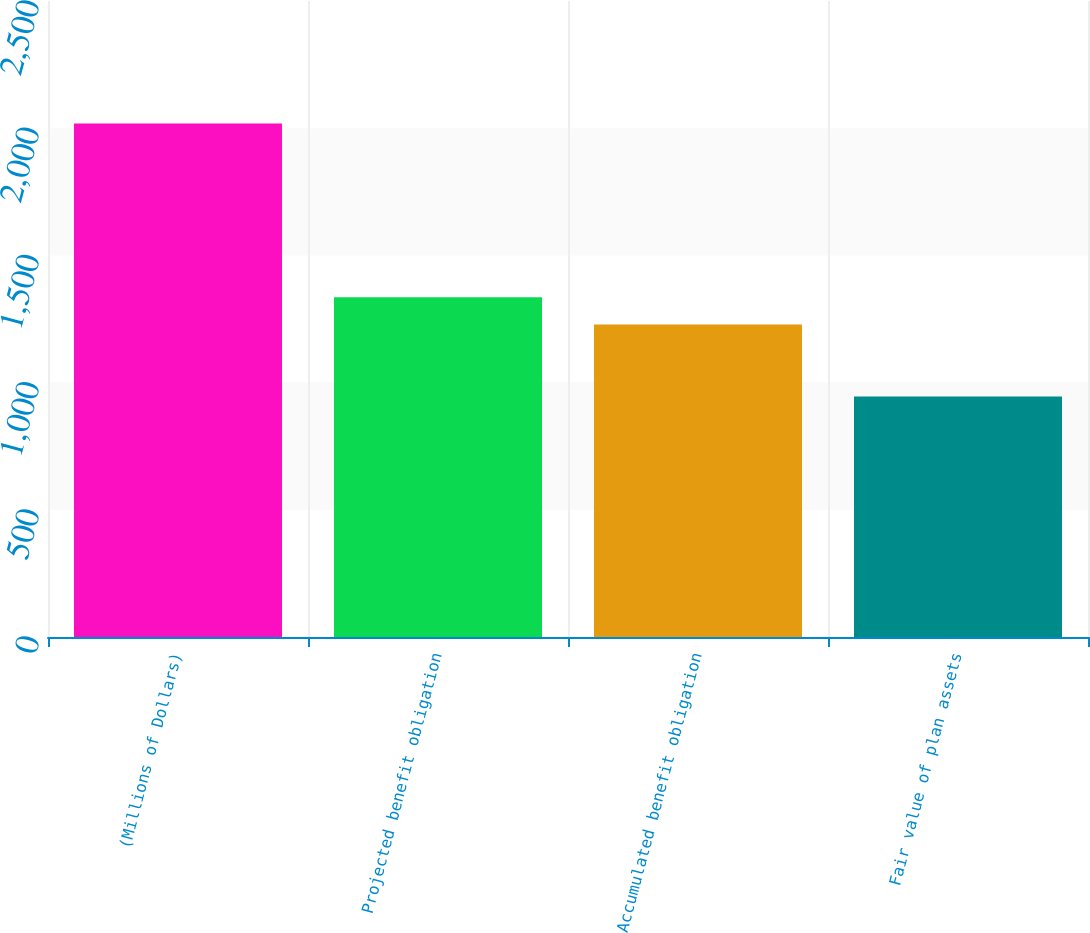<chart> <loc_0><loc_0><loc_500><loc_500><bar_chart><fcel>(Millions of Dollars)<fcel>Projected benefit obligation<fcel>Accumulated benefit obligation<fcel>Fair value of plan assets<nl><fcel>2018<fcel>1335.9<fcel>1228.6<fcel>945<nl></chart> 